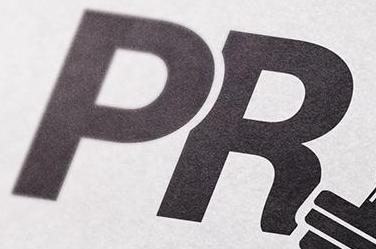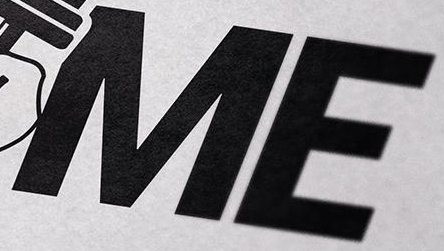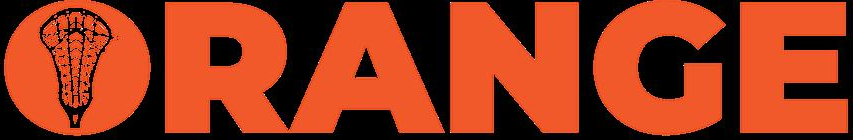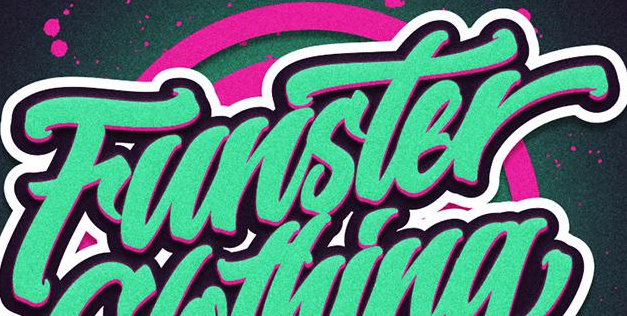What words are shown in these images in order, separated by a semicolon? PR; ME; ORANGE; Funster 